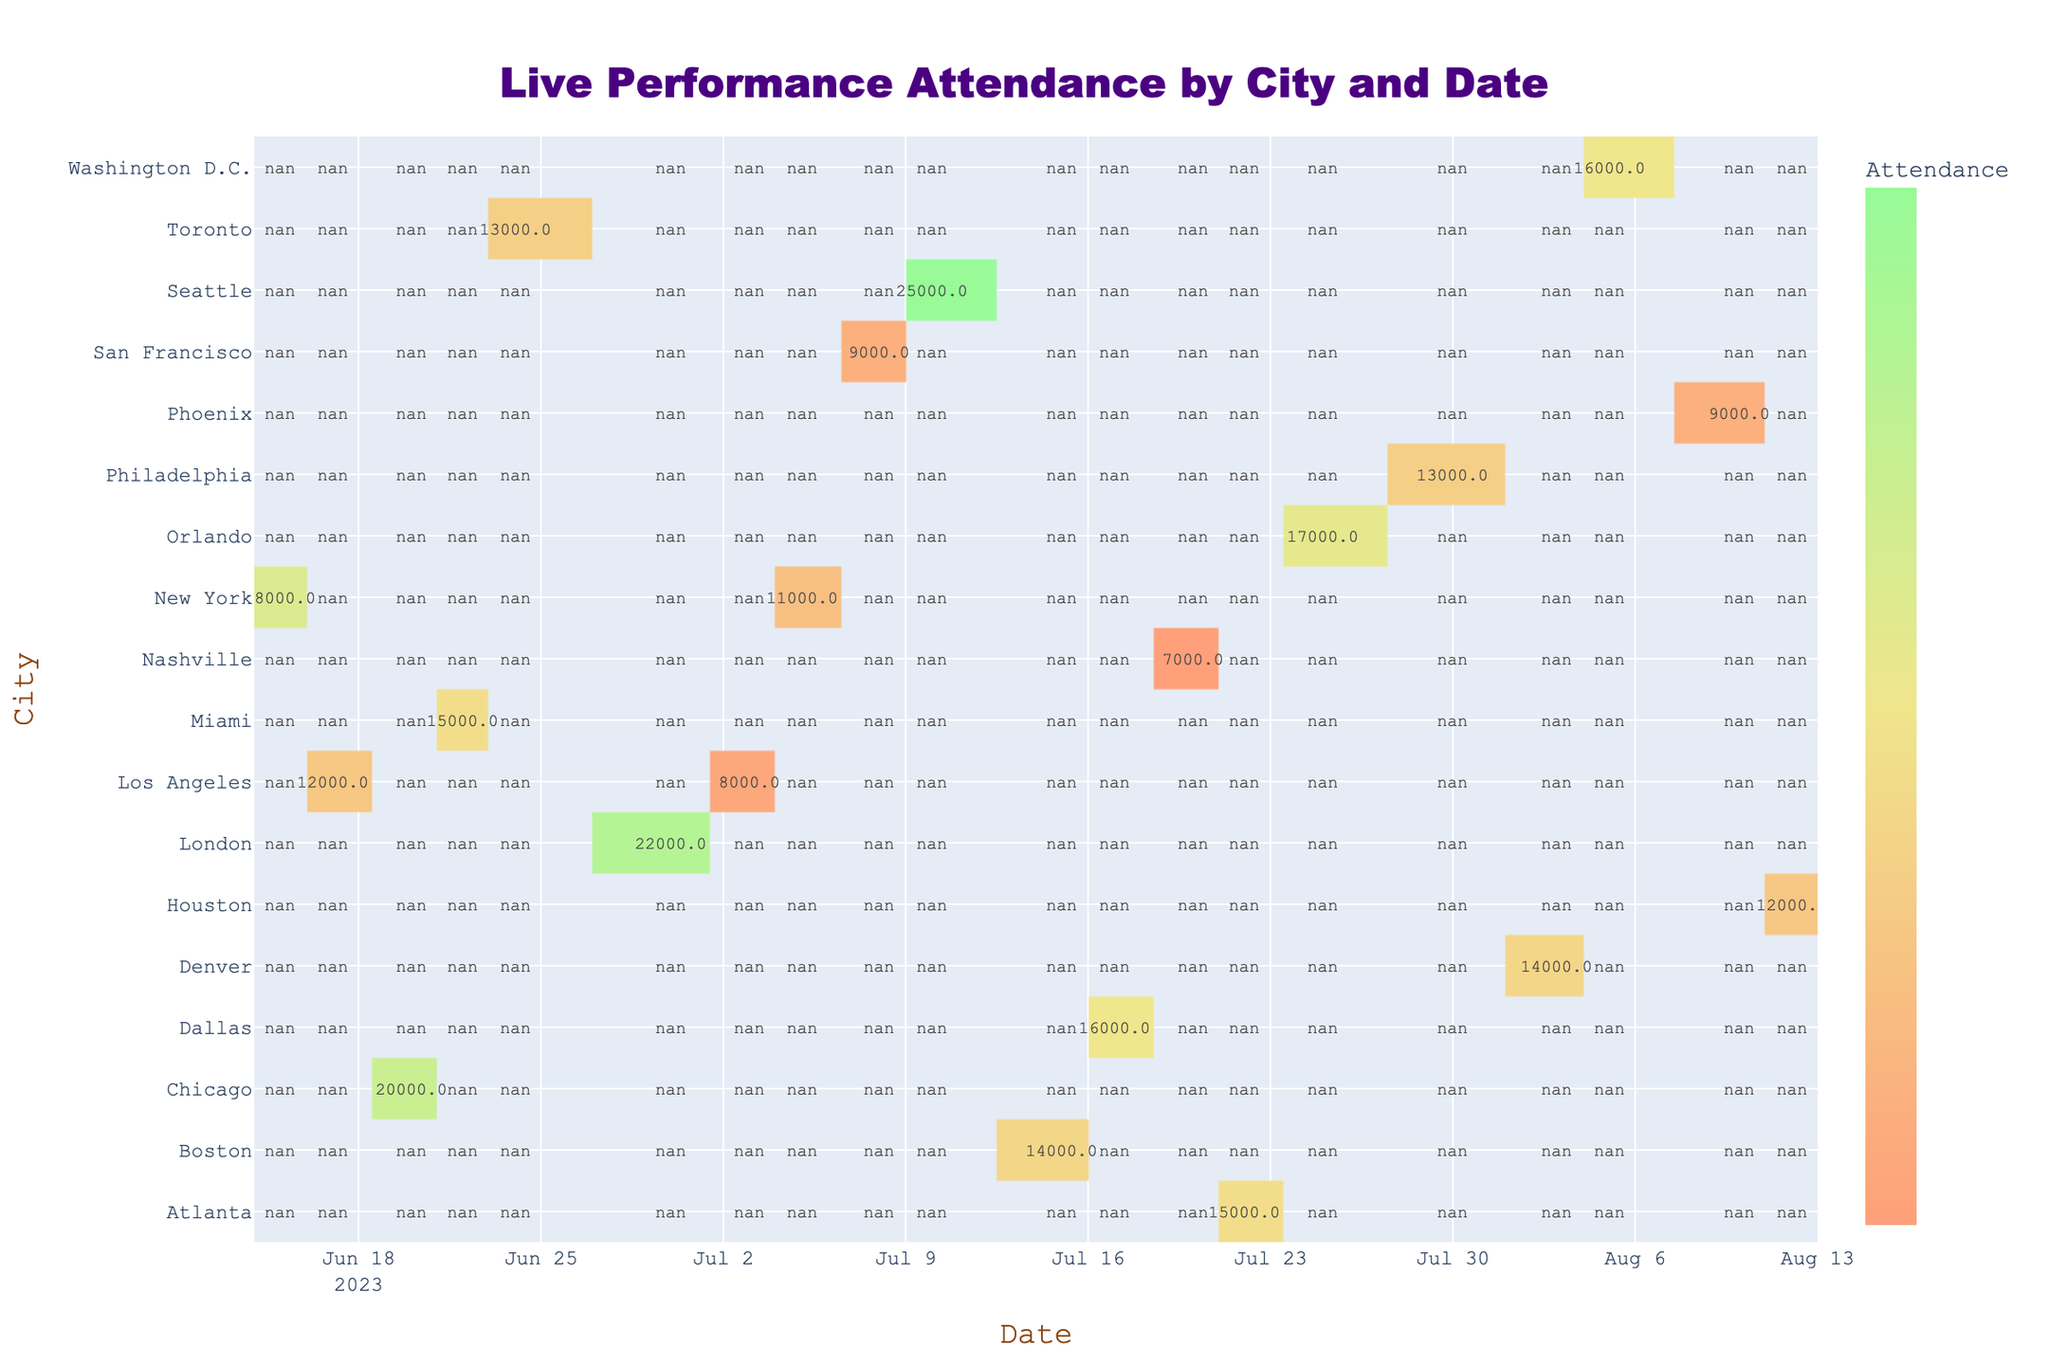What city had the highest attendance for a live performance? Looking at the table, London on 2023-06-30 with Ed Sheeran had the highest attendance recorded at 22,000.
Answer: London Which date had the lowest attendance overall? By examining each attendance value in the table, Nashville on 2023-07-20, with Kacey Musgraves, had the lowest attendance at 7,000.
Answer: 2023-07-20 What is the total attendance for performances in New York? The performances in New York are on 2023-06-15 with 18,000 and 2023-07-05 with 11,000. Summing these gives 18,000 + 11,000 = 29,000.
Answer: 29,000 Did Los Angeles have a performance with more than 15,000 attendees? Checking the values for Los Angeles shows that on 2023-06-17 the attendance was 12,000 and on 2023-07-03 it was 8,000. Both are less than 15,000. Therefore, no, Los Angeles did not have any performance with more than 15,000 attendees.
Answer: No What was the average attendance across all performances? To find the average, sum all attendance values: 18,000 + 12,000 + 20,000 + 15,000 + 13,000 + 22,000 + 8,000 + 11,000 + 9,000 + 25,000 + 14,000 + 16,000 + 7,000 + 15,000 + 17,000 + 13,000 + 14,000 + 16,000 + 9,000 + 12,000 =  319,000. There are 20 performances, so the average is 319,000 / 20 = 15,950.
Answer: 15,950 Which artist had the highest attendance and in which city? The artist with the highest attendance is Ed Sheeran in London with 22,000 attendees on 2023-06-30.
Answer: Ed Sheeran, London How many performances had attendances over 15,000? Counting the values in the table: New York (18,000), Chicago (20,000), Miami (15,000), London (22,000), Boston (14,000), Dallas (16,000), Atlanta (15,000), Orlando (17,000), Washington D.C. (16,000). That's a total of 8 performances over 15,000.
Answer: 8 Which artist had the lowest attendance? The artist with the lowest attendance is Kacey Musgraves in Nashville on 2023-07-20, with only 7,000 attendees.
Answer: Kacey Musgraves What is the total attendance in July? The performances in July include: New York (11,000), San Francisco (9,000), Boston (14,000), Dallas (16,000), Nashville (7,000), Atlanta (15,000), Orlando (17,000), and Washington D.C. (16,000). Summing these gives 11,000 + 9,000 + 14,000 + 16,000 + 7,000 + 15,000 + 17,000 + 16,000 = 89,000.
Answer: 89,000 Which city hosted the most performances? Reviewing the data, each city has one performance scheduled, indicating no city hosted more than one performance during this timeframe. Therefore, all cities are equal.
Answer: All cities are equal 